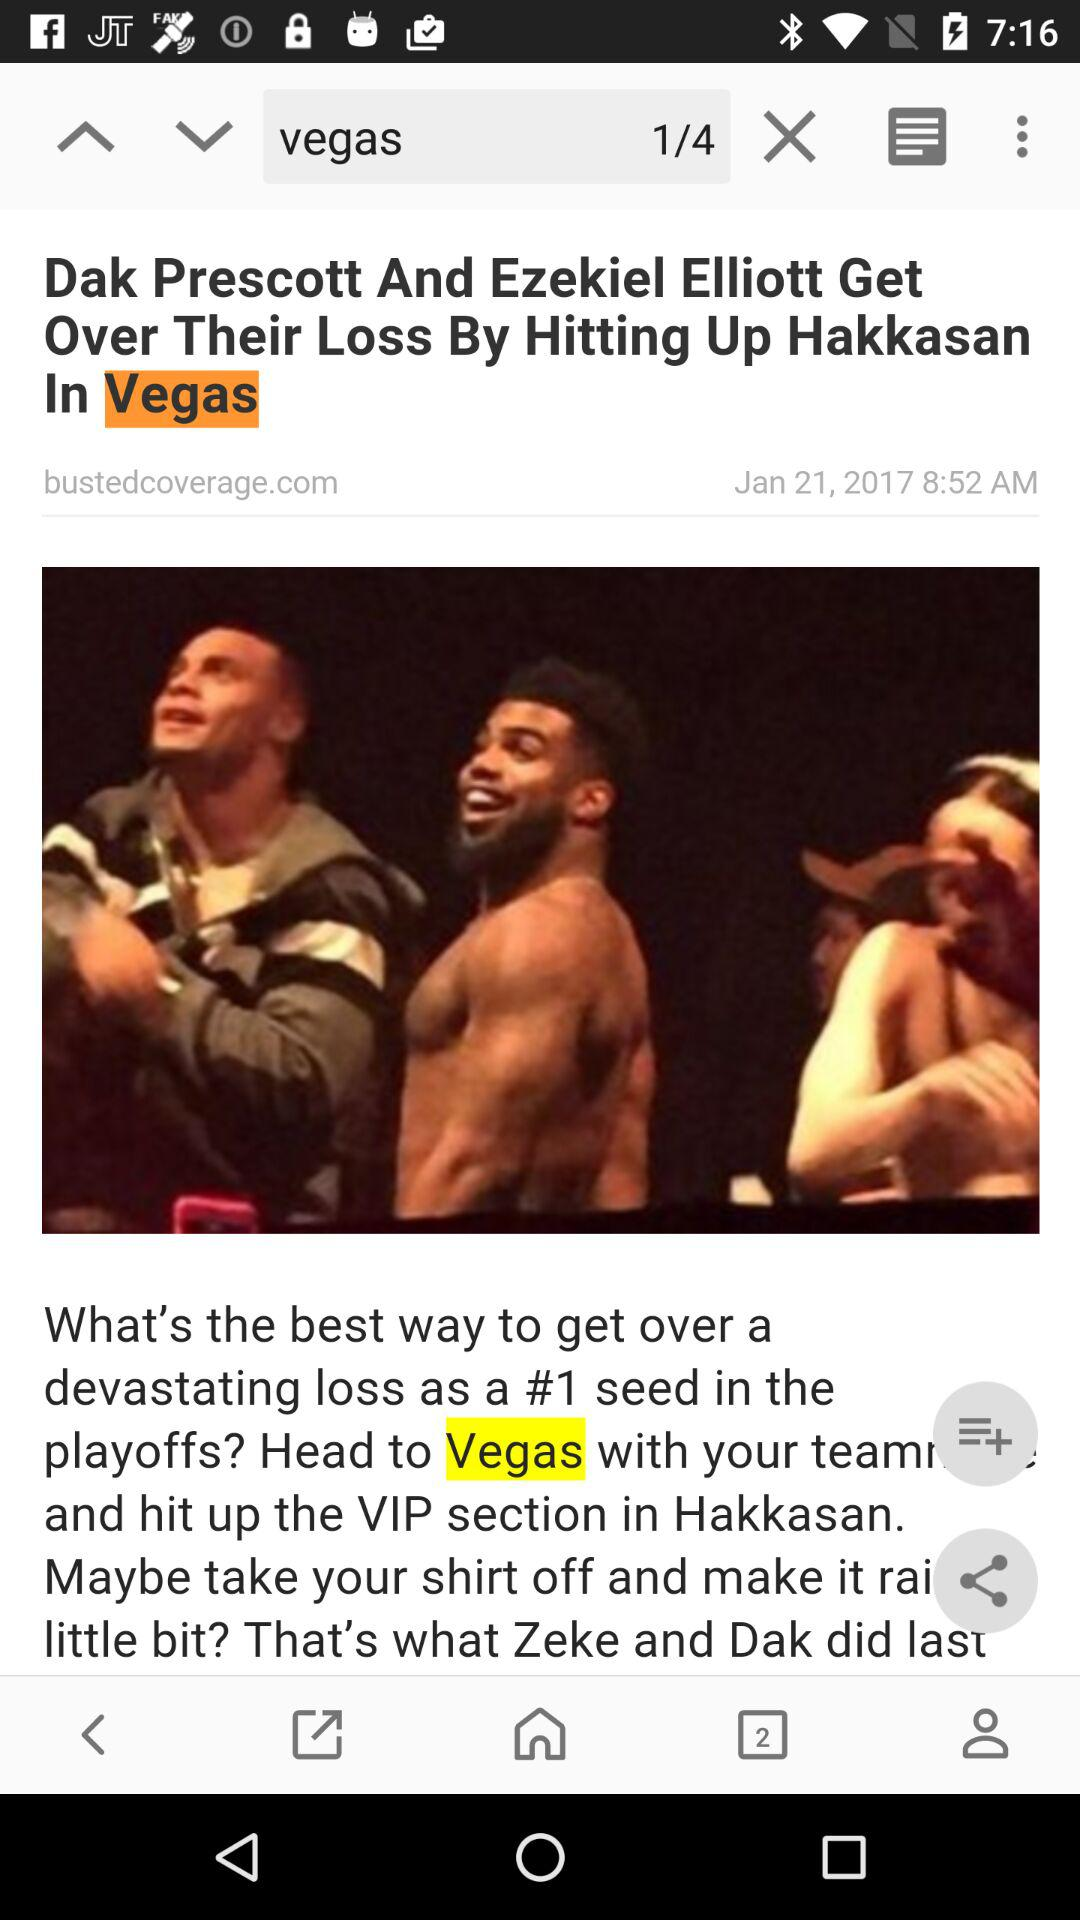When was the article posted? The article was posted on January 21, 2017. 